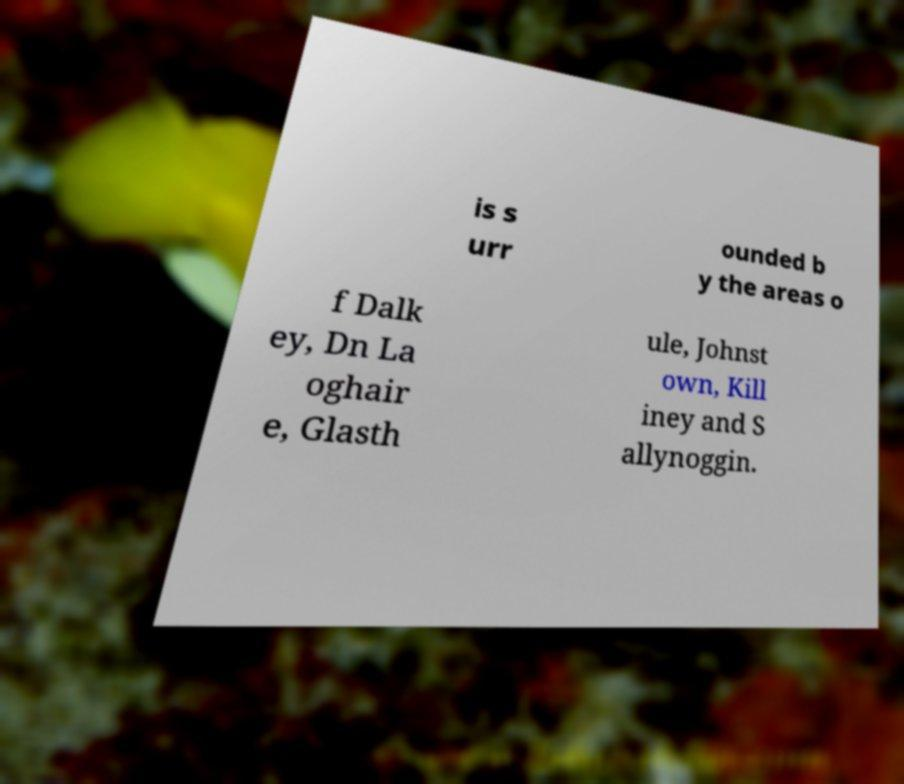Can you accurately transcribe the text from the provided image for me? is s urr ounded b y the areas o f Dalk ey, Dn La oghair e, Glasth ule, Johnst own, Kill iney and S allynoggin. 